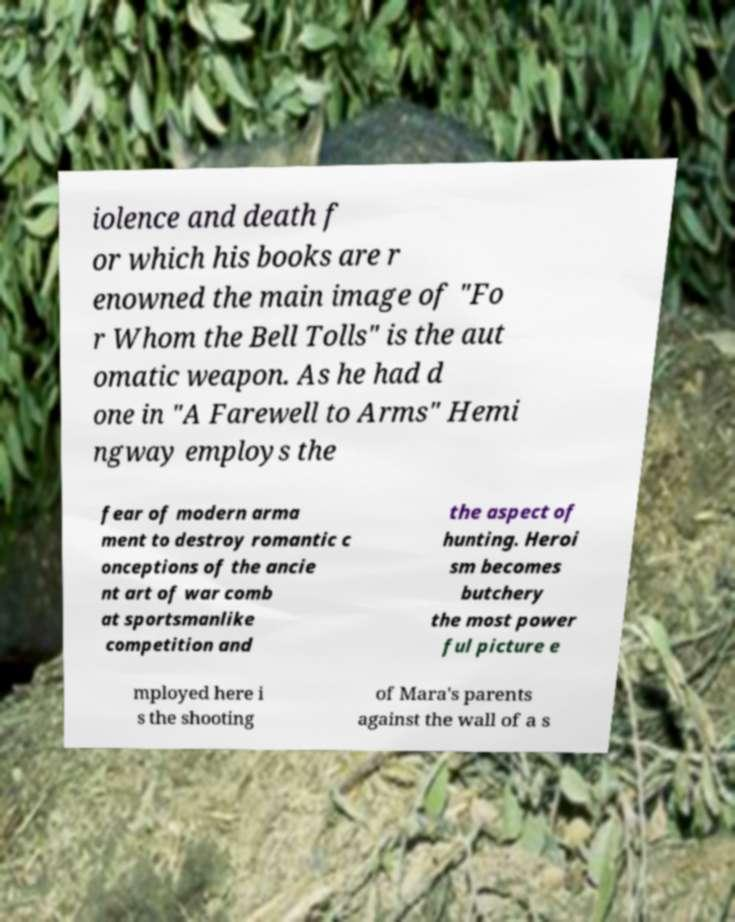Please read and relay the text visible in this image. What does it say? iolence and death f or which his books are r enowned the main image of "Fo r Whom the Bell Tolls" is the aut omatic weapon. As he had d one in "A Farewell to Arms" Hemi ngway employs the fear of modern arma ment to destroy romantic c onceptions of the ancie nt art of war comb at sportsmanlike competition and the aspect of hunting. Heroi sm becomes butchery the most power ful picture e mployed here i s the shooting of Mara's parents against the wall of a s 